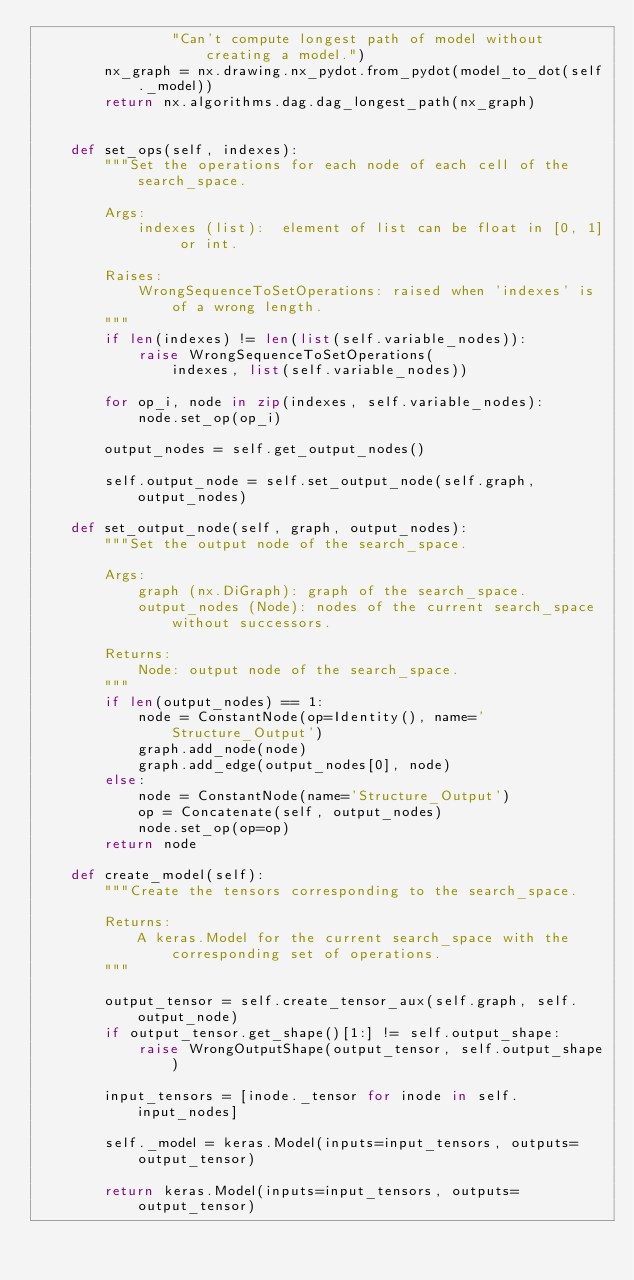Convert code to text. <code><loc_0><loc_0><loc_500><loc_500><_Python_>                "Can't compute longest path of model without creating a model.")
        nx_graph = nx.drawing.nx_pydot.from_pydot(model_to_dot(self._model))
        return nx.algorithms.dag.dag_longest_path(nx_graph)


    def set_ops(self, indexes):
        """Set the operations for each node of each cell of the search_space.

        Args:
            indexes (list):  element of list can be float in [0, 1] or int.

        Raises:
            WrongSequenceToSetOperations: raised when 'indexes' is of a wrong length.
        """
        if len(indexes) != len(list(self.variable_nodes)):
            raise WrongSequenceToSetOperations(
                indexes, list(self.variable_nodes))

        for op_i, node in zip(indexes, self.variable_nodes):
            node.set_op(op_i)

        output_nodes = self.get_output_nodes()

        self.output_node = self.set_output_node(self.graph, output_nodes)

    def set_output_node(self, graph, output_nodes):
        """Set the output node of the search_space.

        Args:
            graph (nx.DiGraph): graph of the search_space.
            output_nodes (Node): nodes of the current search_space without successors.

        Returns:
            Node: output node of the search_space.
        """
        if len(output_nodes) == 1:
            node = ConstantNode(op=Identity(), name='Structure_Output')
            graph.add_node(node)
            graph.add_edge(output_nodes[0], node)
        else:
            node = ConstantNode(name='Structure_Output')
            op = Concatenate(self, output_nodes)
            node.set_op(op=op)
        return node

    def create_model(self):
        """Create the tensors corresponding to the search_space.

        Returns:
            A keras.Model for the current search_space with the corresponding set of operations.
        """

        output_tensor = self.create_tensor_aux(self.graph, self.output_node)
        if output_tensor.get_shape()[1:] != self.output_shape:
            raise WrongOutputShape(output_tensor, self.output_shape)

        input_tensors = [inode._tensor for inode in self.input_nodes]

        self._model = keras.Model(inputs=input_tensors, outputs=output_tensor)

        return keras.Model(inputs=input_tensors, outputs=output_tensor)
</code> 